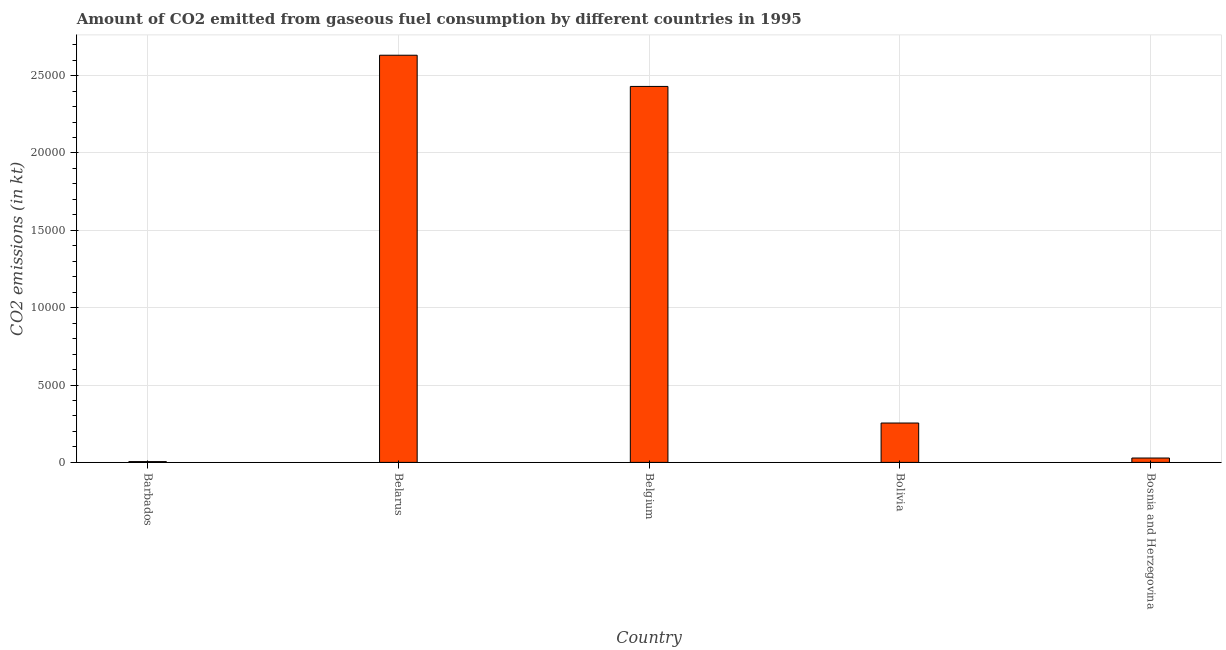What is the title of the graph?
Ensure brevity in your answer.  Amount of CO2 emitted from gaseous fuel consumption by different countries in 1995. What is the label or title of the X-axis?
Ensure brevity in your answer.  Country. What is the label or title of the Y-axis?
Offer a very short reply. CO2 emissions (in kt). What is the co2 emissions from gaseous fuel consumption in Bosnia and Herzegovina?
Provide a succinct answer. 282.36. Across all countries, what is the maximum co2 emissions from gaseous fuel consumption?
Keep it short and to the point. 2.63e+04. Across all countries, what is the minimum co2 emissions from gaseous fuel consumption?
Give a very brief answer. 51.34. In which country was the co2 emissions from gaseous fuel consumption maximum?
Your answer should be very brief. Belarus. In which country was the co2 emissions from gaseous fuel consumption minimum?
Provide a short and direct response. Barbados. What is the sum of the co2 emissions from gaseous fuel consumption?
Provide a short and direct response. 5.35e+04. What is the difference between the co2 emissions from gaseous fuel consumption in Belarus and Belgium?
Give a very brief answer. 2016.85. What is the average co2 emissions from gaseous fuel consumption per country?
Your answer should be compact. 1.07e+04. What is the median co2 emissions from gaseous fuel consumption?
Your answer should be compact. 2544.9. In how many countries, is the co2 emissions from gaseous fuel consumption greater than 19000 kt?
Give a very brief answer. 2. What is the ratio of the co2 emissions from gaseous fuel consumption in Belgium to that in Bolivia?
Keep it short and to the point. 9.55. Is the co2 emissions from gaseous fuel consumption in Barbados less than that in Bolivia?
Give a very brief answer. Yes. What is the difference between the highest and the second highest co2 emissions from gaseous fuel consumption?
Offer a terse response. 2016.85. What is the difference between the highest and the lowest co2 emissions from gaseous fuel consumption?
Offer a very short reply. 2.63e+04. How many bars are there?
Your answer should be very brief. 5. Are all the bars in the graph horizontal?
Offer a very short reply. No. How many countries are there in the graph?
Keep it short and to the point. 5. What is the difference between two consecutive major ticks on the Y-axis?
Provide a short and direct response. 5000. Are the values on the major ticks of Y-axis written in scientific E-notation?
Make the answer very short. No. What is the CO2 emissions (in kt) in Barbados?
Offer a terse response. 51.34. What is the CO2 emissions (in kt) in Belarus?
Provide a short and direct response. 2.63e+04. What is the CO2 emissions (in kt) of Belgium?
Give a very brief answer. 2.43e+04. What is the CO2 emissions (in kt) in Bolivia?
Your answer should be very brief. 2544.9. What is the CO2 emissions (in kt) of Bosnia and Herzegovina?
Make the answer very short. 282.36. What is the difference between the CO2 emissions (in kt) in Barbados and Belarus?
Provide a succinct answer. -2.63e+04. What is the difference between the CO2 emissions (in kt) in Barbados and Belgium?
Offer a terse response. -2.42e+04. What is the difference between the CO2 emissions (in kt) in Barbados and Bolivia?
Your response must be concise. -2493.56. What is the difference between the CO2 emissions (in kt) in Barbados and Bosnia and Herzegovina?
Make the answer very short. -231.02. What is the difference between the CO2 emissions (in kt) in Belarus and Belgium?
Offer a very short reply. 2016.85. What is the difference between the CO2 emissions (in kt) in Belarus and Bolivia?
Your answer should be very brief. 2.38e+04. What is the difference between the CO2 emissions (in kt) in Belarus and Bosnia and Herzegovina?
Keep it short and to the point. 2.60e+04. What is the difference between the CO2 emissions (in kt) in Belgium and Bolivia?
Your response must be concise. 2.18e+04. What is the difference between the CO2 emissions (in kt) in Belgium and Bosnia and Herzegovina?
Give a very brief answer. 2.40e+04. What is the difference between the CO2 emissions (in kt) in Bolivia and Bosnia and Herzegovina?
Your answer should be very brief. 2262.54. What is the ratio of the CO2 emissions (in kt) in Barbados to that in Belarus?
Provide a short and direct response. 0. What is the ratio of the CO2 emissions (in kt) in Barbados to that in Belgium?
Provide a succinct answer. 0. What is the ratio of the CO2 emissions (in kt) in Barbados to that in Bolivia?
Make the answer very short. 0.02. What is the ratio of the CO2 emissions (in kt) in Barbados to that in Bosnia and Herzegovina?
Make the answer very short. 0.18. What is the ratio of the CO2 emissions (in kt) in Belarus to that in Belgium?
Keep it short and to the point. 1.08. What is the ratio of the CO2 emissions (in kt) in Belarus to that in Bolivia?
Make the answer very short. 10.34. What is the ratio of the CO2 emissions (in kt) in Belarus to that in Bosnia and Herzegovina?
Your answer should be very brief. 93.21. What is the ratio of the CO2 emissions (in kt) in Belgium to that in Bolivia?
Make the answer very short. 9.55. What is the ratio of the CO2 emissions (in kt) in Belgium to that in Bosnia and Herzegovina?
Give a very brief answer. 86.06. What is the ratio of the CO2 emissions (in kt) in Bolivia to that in Bosnia and Herzegovina?
Provide a succinct answer. 9.01. 